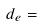<formula> <loc_0><loc_0><loc_500><loc_500>d _ { e } =</formula> 